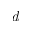Convert formula to latex. <formula><loc_0><loc_0><loc_500><loc_500>d</formula> 